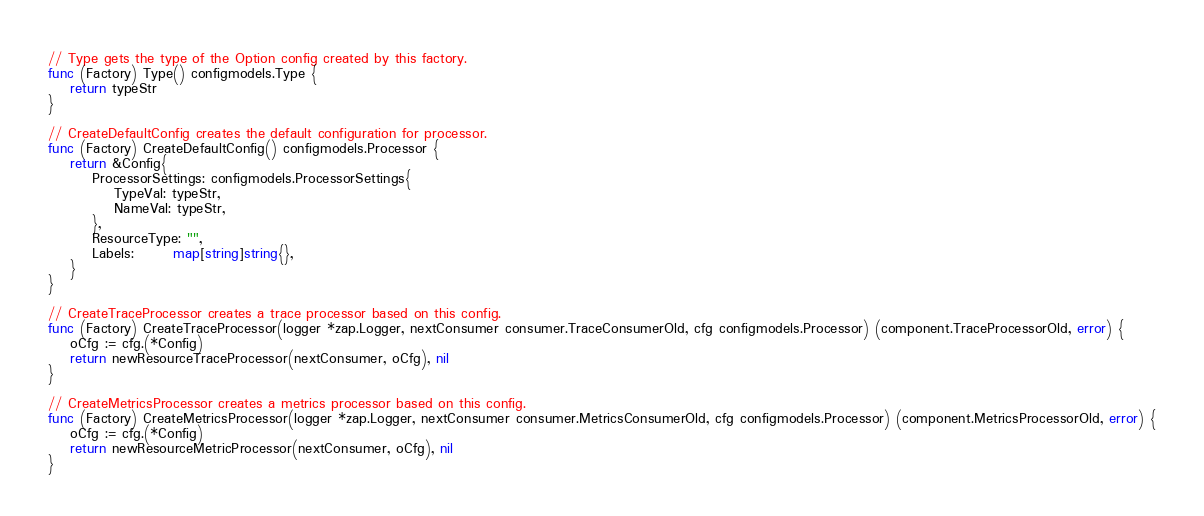<code> <loc_0><loc_0><loc_500><loc_500><_Go_>// Type gets the type of the Option config created by this factory.
func (Factory) Type() configmodels.Type {
	return typeStr
}

// CreateDefaultConfig creates the default configuration for processor.
func (Factory) CreateDefaultConfig() configmodels.Processor {
	return &Config{
		ProcessorSettings: configmodels.ProcessorSettings{
			TypeVal: typeStr,
			NameVal: typeStr,
		},
		ResourceType: "",
		Labels:       map[string]string{},
	}
}

// CreateTraceProcessor creates a trace processor based on this config.
func (Factory) CreateTraceProcessor(logger *zap.Logger, nextConsumer consumer.TraceConsumerOld, cfg configmodels.Processor) (component.TraceProcessorOld, error) {
	oCfg := cfg.(*Config)
	return newResourceTraceProcessor(nextConsumer, oCfg), nil
}

// CreateMetricsProcessor creates a metrics processor based on this config.
func (Factory) CreateMetricsProcessor(logger *zap.Logger, nextConsumer consumer.MetricsConsumerOld, cfg configmodels.Processor) (component.MetricsProcessorOld, error) {
	oCfg := cfg.(*Config)
	return newResourceMetricProcessor(nextConsumer, oCfg), nil
}
</code> 